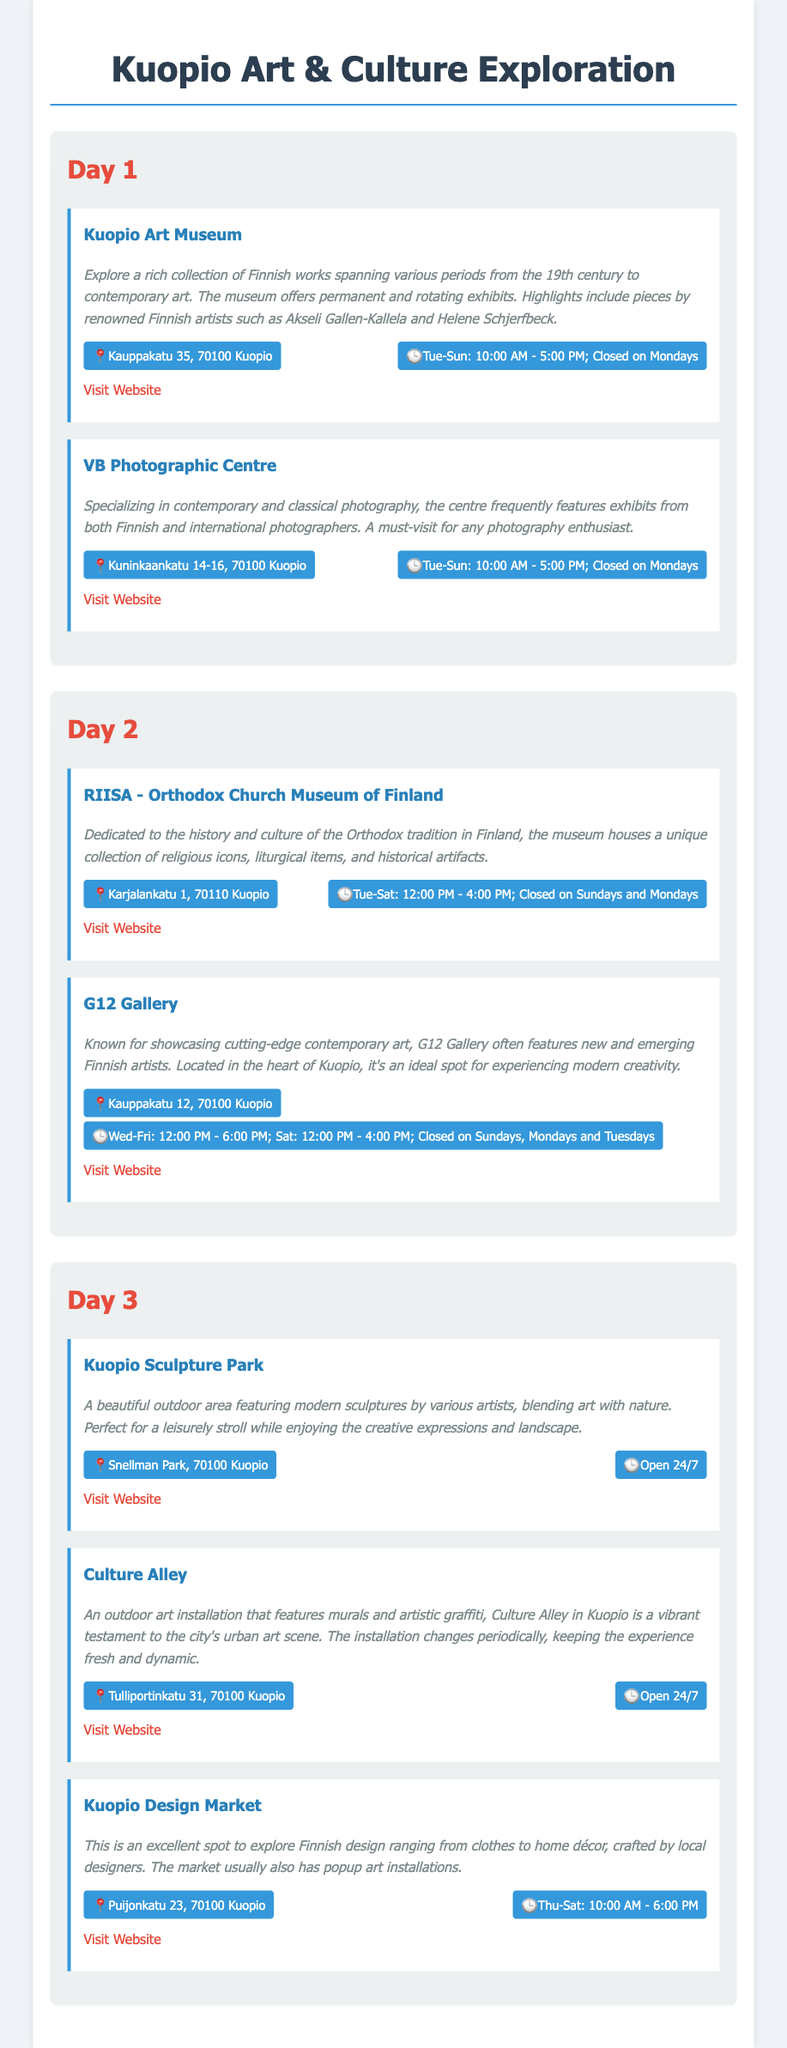what are the opening days of Kuopio Art Museum? The document states that Kuopio Art Museum is open from Tuesday to Sunday and closed on Mondays.
Answer: Tue-Sun what is the address of VB Photographic Centre? The address is specified in the document as Kuninkaankatu 14-16, 70100 Kuopio.
Answer: Kuninkaankatu 14-16, 70100 Kuopio how many days is the RIISA - Orthodox Church Museum of Finland open? The document indicates that RIISA is open for 5 days a week (Tuesday to Saturday).
Answer: 5 days which gallery is known for showcasing emerging Finnish artists? The document mentions G12 Gallery as a place that showcases new and emerging Finnish artists.
Answer: G12 Gallery what is featured in Culture Alley? The document describes Culture Alley as having murals and artistic graffiti.
Answer: Murals and artistic graffiti when does Kuopio Design Market operate? The document states that the Kuopio Design Market operates from Thursday to Saturday.
Answer: Thu-Sat how long is Kuopio Sculpture Park open? The document states that Kuopio Sculpture Park is open 24/7.
Answer: 24/7 what type of art does the VB Photographic Centre specialize in? The document mentions that VB Photographic Centre specializes in contemporary and classical photography.
Answer: Photography 